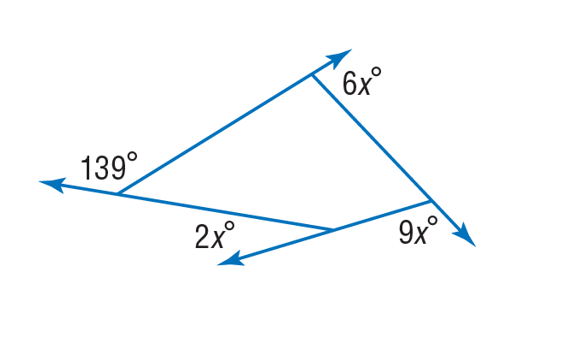Answer the mathemtical geometry problem and directly provide the correct option letter.
Question: Find the value of x in the diagram.
Choices: A: 13 B: 26 C: 52 D: 70 A 